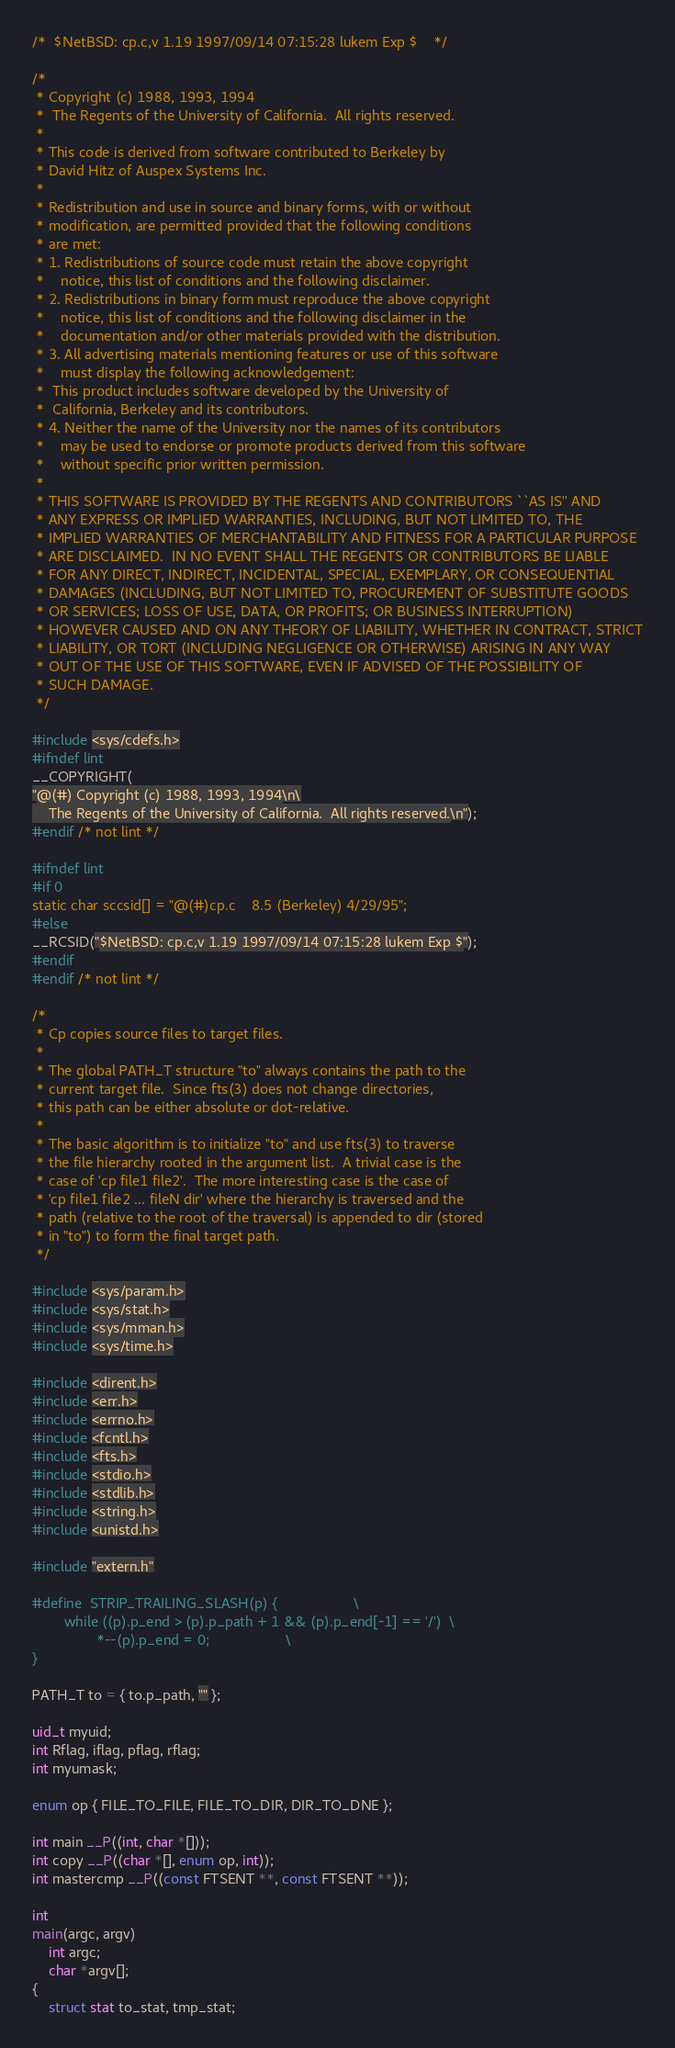<code> <loc_0><loc_0><loc_500><loc_500><_C_>/*	$NetBSD: cp.c,v 1.19 1997/09/14 07:15:28 lukem Exp $	*/

/*
 * Copyright (c) 1988, 1993, 1994
 *	The Regents of the University of California.  All rights reserved.
 *
 * This code is derived from software contributed to Berkeley by
 * David Hitz of Auspex Systems Inc.
 *
 * Redistribution and use in source and binary forms, with or without
 * modification, are permitted provided that the following conditions
 * are met:
 * 1. Redistributions of source code must retain the above copyright
 *    notice, this list of conditions and the following disclaimer.
 * 2. Redistributions in binary form must reproduce the above copyright
 *    notice, this list of conditions and the following disclaimer in the
 *    documentation and/or other materials provided with the distribution.
 * 3. All advertising materials mentioning features or use of this software
 *    must display the following acknowledgement:
 *	This product includes software developed by the University of
 *	California, Berkeley and its contributors.
 * 4. Neither the name of the University nor the names of its contributors
 *    may be used to endorse or promote products derived from this software
 *    without specific prior written permission.
 *
 * THIS SOFTWARE IS PROVIDED BY THE REGENTS AND CONTRIBUTORS ``AS IS'' AND
 * ANY EXPRESS OR IMPLIED WARRANTIES, INCLUDING, BUT NOT LIMITED TO, THE
 * IMPLIED WARRANTIES OF MERCHANTABILITY AND FITNESS FOR A PARTICULAR PURPOSE
 * ARE DISCLAIMED.  IN NO EVENT SHALL THE REGENTS OR CONTRIBUTORS BE LIABLE
 * FOR ANY DIRECT, INDIRECT, INCIDENTAL, SPECIAL, EXEMPLARY, OR CONSEQUENTIAL
 * DAMAGES (INCLUDING, BUT NOT LIMITED TO, PROCUREMENT OF SUBSTITUTE GOODS
 * OR SERVICES; LOSS OF USE, DATA, OR PROFITS; OR BUSINESS INTERRUPTION)
 * HOWEVER CAUSED AND ON ANY THEORY OF LIABILITY, WHETHER IN CONTRACT, STRICT
 * LIABILITY, OR TORT (INCLUDING NEGLIGENCE OR OTHERWISE) ARISING IN ANY WAY
 * OUT OF THE USE OF THIS SOFTWARE, EVEN IF ADVISED OF THE POSSIBILITY OF
 * SUCH DAMAGE.
 */

#include <sys/cdefs.h>
#ifndef lint
__COPYRIGHT(
"@(#) Copyright (c) 1988, 1993, 1994\n\
	The Regents of the University of California.  All rights reserved.\n");
#endif /* not lint */

#ifndef lint
#if 0
static char sccsid[] = "@(#)cp.c	8.5 (Berkeley) 4/29/95";
#else
__RCSID("$NetBSD: cp.c,v 1.19 1997/09/14 07:15:28 lukem Exp $");
#endif
#endif /* not lint */

/*
 * Cp copies source files to target files.
 * 
 * The global PATH_T structure "to" always contains the path to the
 * current target file.  Since fts(3) does not change directories,
 * this path can be either absolute or dot-relative.
 * 
 * The basic algorithm is to initialize "to" and use fts(3) to traverse
 * the file hierarchy rooted in the argument list.  A trivial case is the
 * case of 'cp file1 file2'.  The more interesting case is the case of
 * 'cp file1 file2 ... fileN dir' where the hierarchy is traversed and the
 * path (relative to the root of the traversal) is appended to dir (stored
 * in "to") to form the final target path.
 */

#include <sys/param.h>
#include <sys/stat.h>
#include <sys/mman.h>
#include <sys/time.h>

#include <dirent.h>
#include <err.h>
#include <errno.h>
#include <fcntl.h>
#include <fts.h>
#include <stdio.h>
#include <stdlib.h>
#include <string.h>
#include <unistd.h>

#include "extern.h"

#define	STRIP_TRAILING_SLASH(p) {					\
        while ((p).p_end > (p).p_path + 1 && (p).p_end[-1] == '/')	\
                *--(p).p_end = 0;					\
}

PATH_T to = { to.p_path, "" };

uid_t myuid;
int Rflag, iflag, pflag, rflag;
int myumask;

enum op { FILE_TO_FILE, FILE_TO_DIR, DIR_TO_DNE };

int main __P((int, char *[]));
int copy __P((char *[], enum op, int));
int mastercmp __P((const FTSENT **, const FTSENT **));

int
main(argc, argv)
	int argc;
	char *argv[];
{
	struct stat to_stat, tmp_stat;</code> 